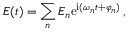Convert formula to latex. <formula><loc_0><loc_0><loc_500><loc_500>E ( t ) = \sum _ { n } E _ { n } e ^ { i ( \omega _ { n } t + \varphi _ { n } ) } \, ,</formula> 